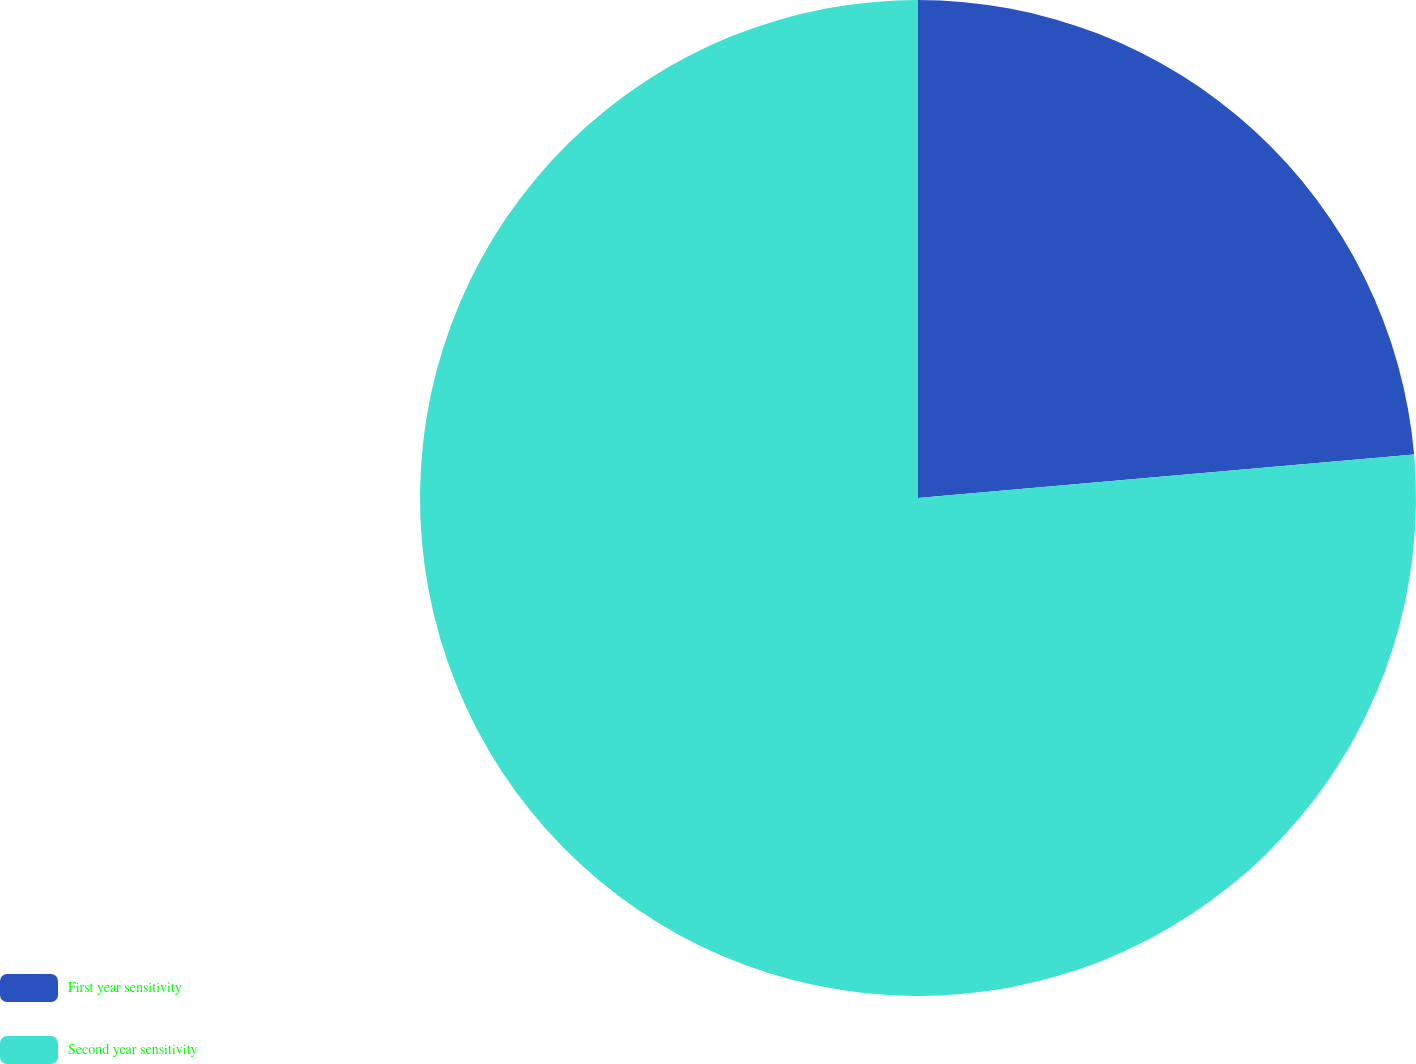<chart> <loc_0><loc_0><loc_500><loc_500><pie_chart><fcel>First year sensitivity<fcel>Second year sensitivity<nl><fcel>23.61%<fcel>76.39%<nl></chart> 